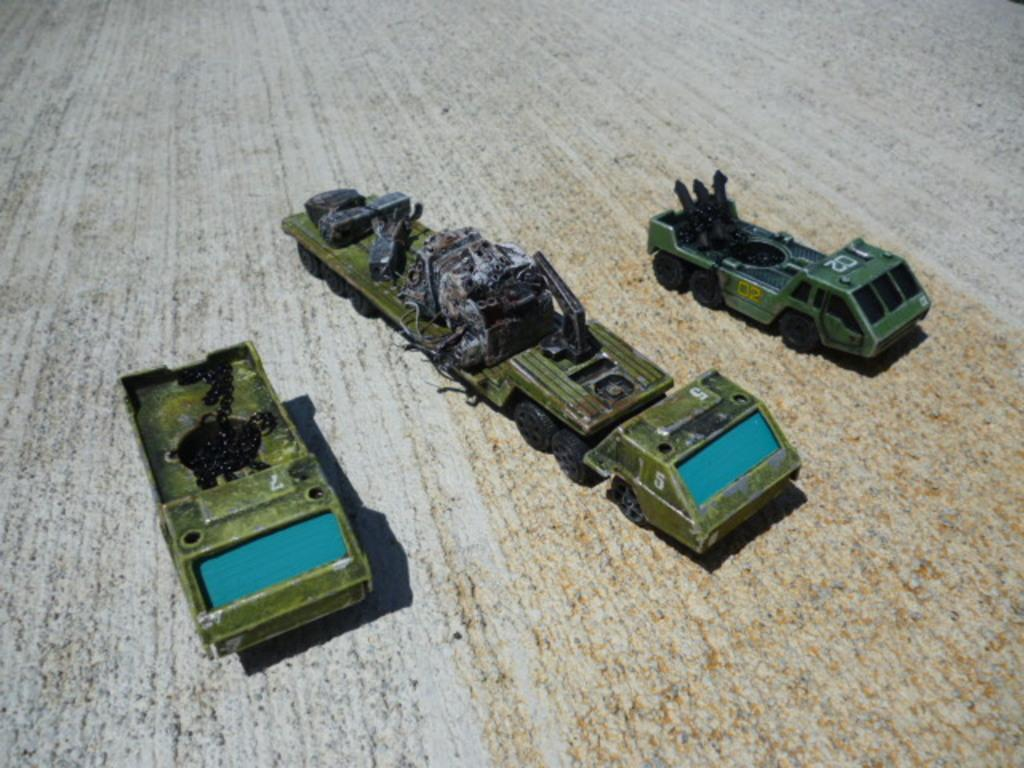What type of toys are present in the image? There are toy vehicles in the image. Are there any additional items on the toy vehicles? Yes, there are objects on the toy vehicles. Where are the toy vehicles and objects located? The toy vehicles and objects are on a platform. What type of cannon is present on the toy vehicles in the image? There is no cannon present on the toy vehicles in the image. What color is the cap on the toy vehicles in the image? There is no cap present on the toy vehicles in the image. 